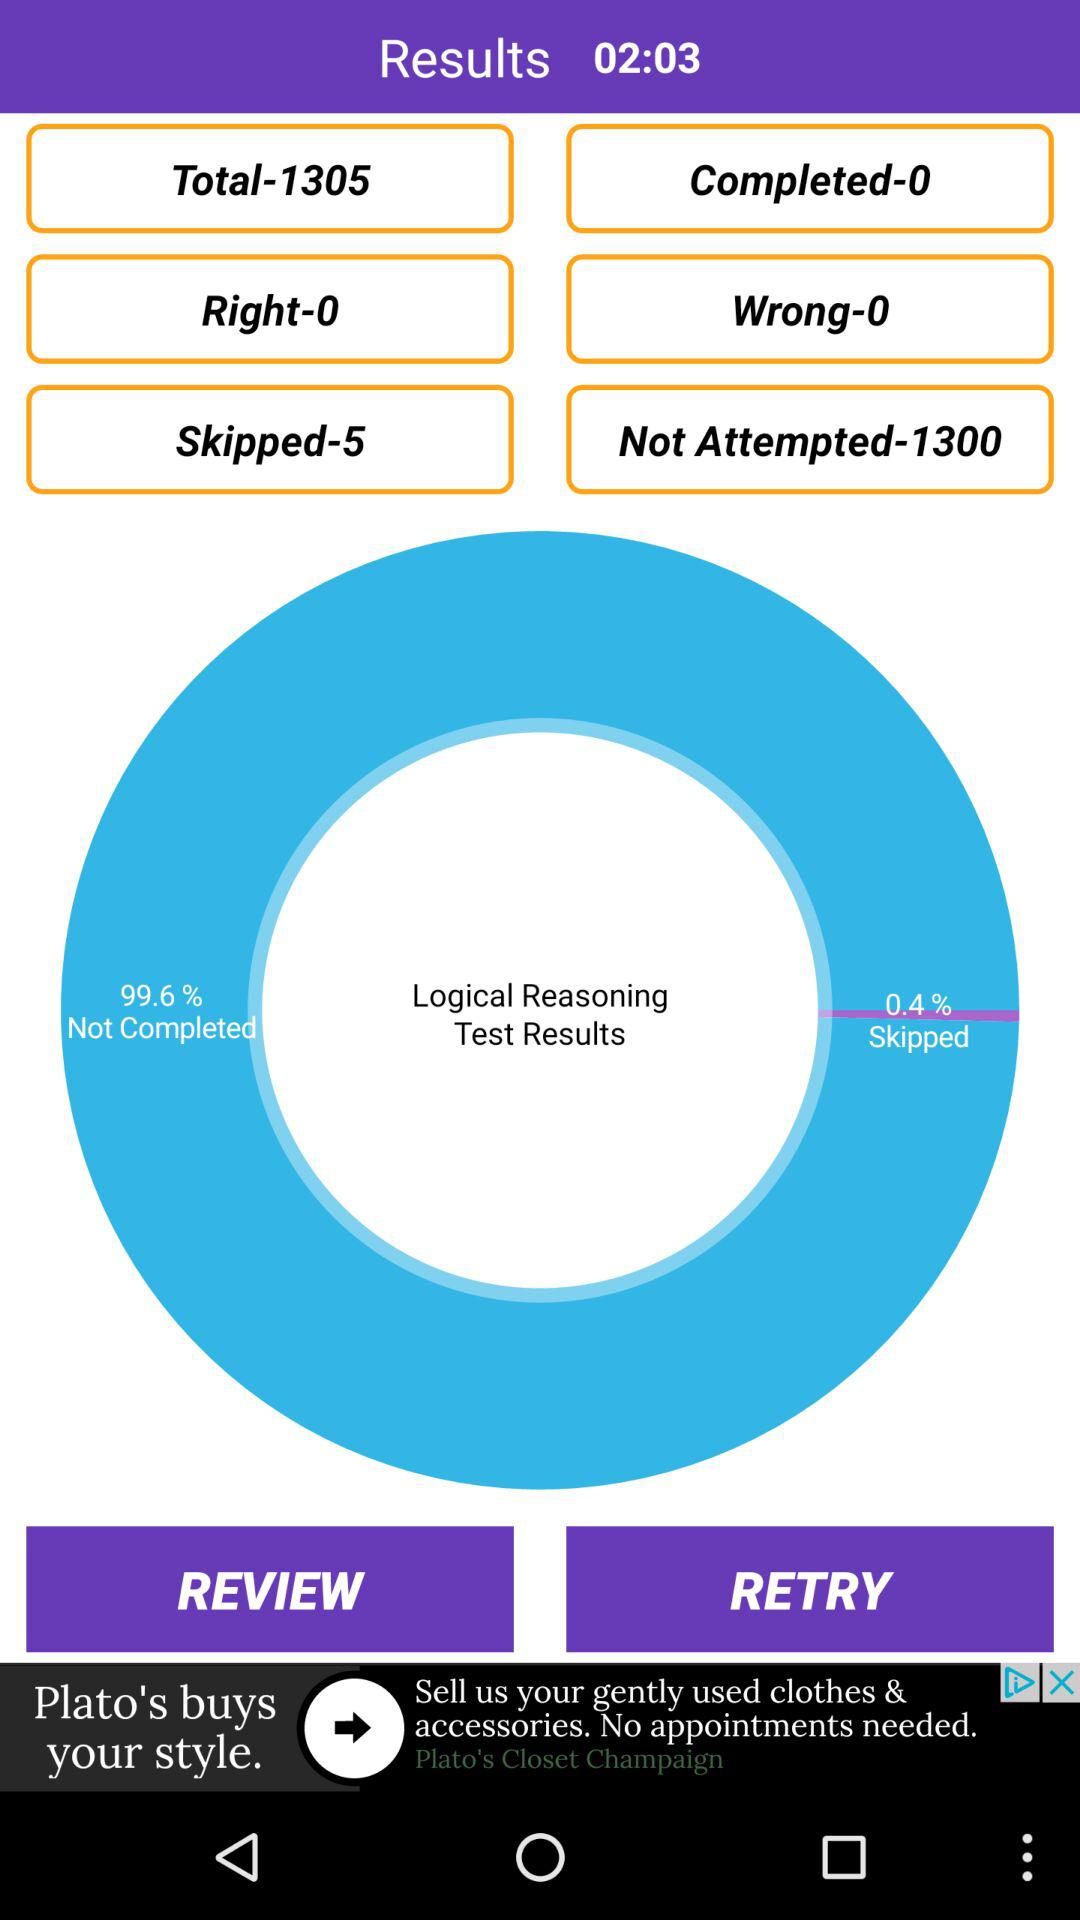What is the count of skipped questions? The count of skipped questions is 5. 